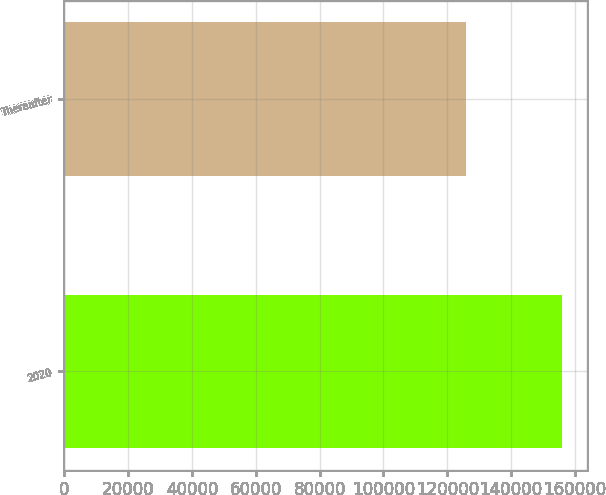<chart> <loc_0><loc_0><loc_500><loc_500><bar_chart><fcel>2020<fcel>Thereafter<nl><fcel>156072<fcel>125881<nl></chart> 